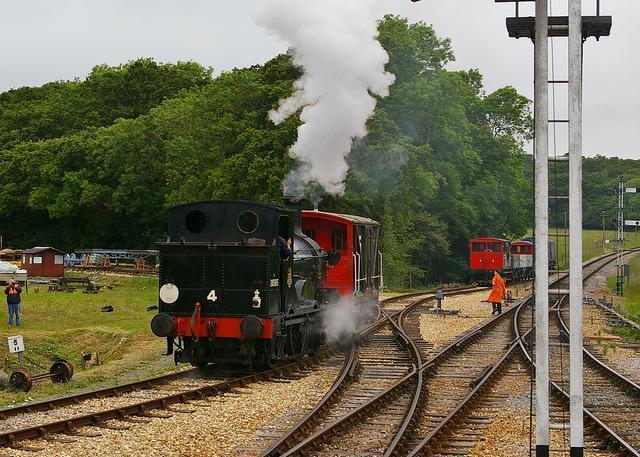Why is the man wearing an orange jacket?
Pick the correct solution from the four options below to address the question.
Options: Visibility, dress code, camouflage, fashion. Visibility. 